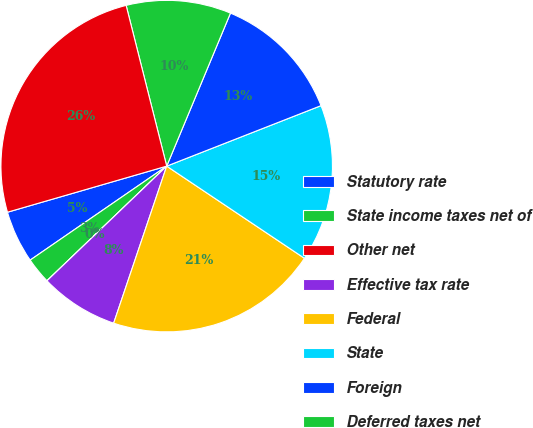Convert chart to OTSL. <chart><loc_0><loc_0><loc_500><loc_500><pie_chart><fcel>Statutory rate<fcel>State income taxes net of<fcel>Other net<fcel>Effective tax rate<fcel>Federal<fcel>State<fcel>Foreign<fcel>Deferred taxes net<fcel>Total<nl><fcel>5.11%<fcel>2.56%<fcel>0.0%<fcel>7.66%<fcel>20.8%<fcel>15.33%<fcel>12.77%<fcel>10.22%<fcel>25.55%<nl></chart> 